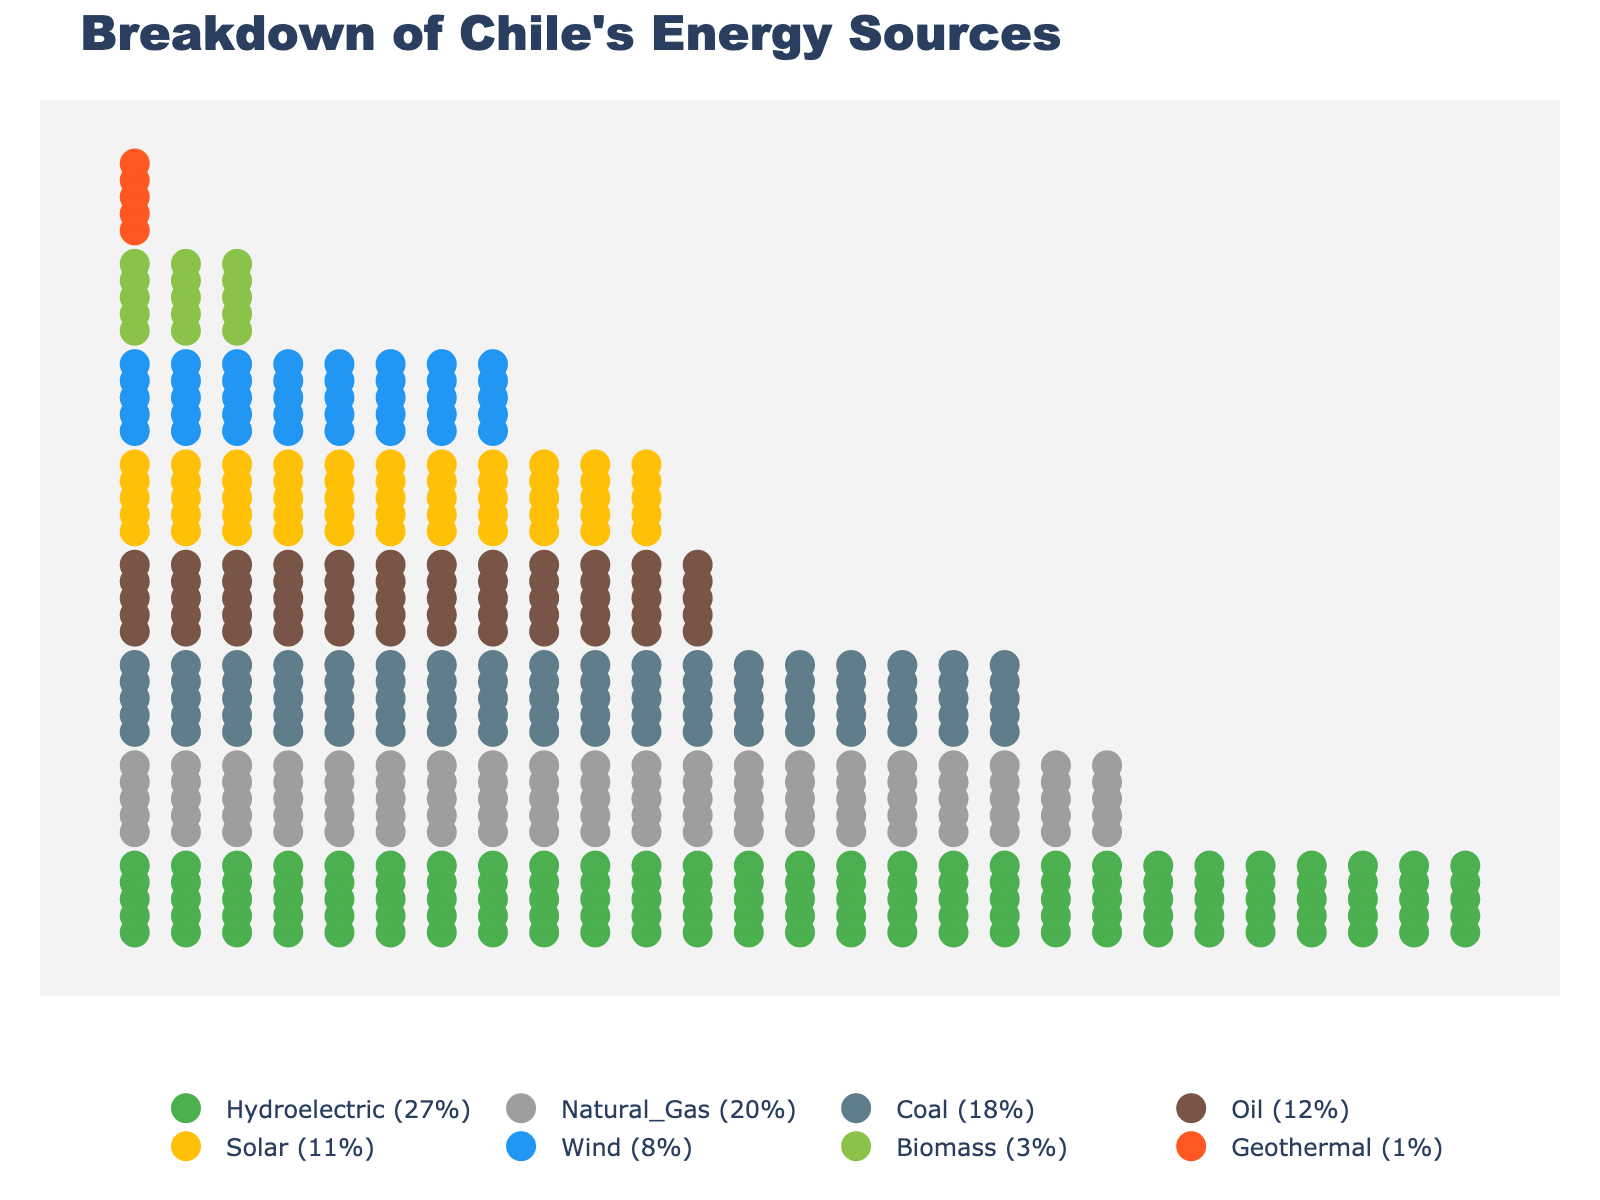what is the title of the plot? The title is usually prominently displayed at the top of the isotype plot. Look for large bold text.
Answer: Breakdown of Chile's Energy Sources Which energy source has the highest percentage? The energy source with the highest percentage will have the most icons arranged horizontally.
Answer: Hydroelectric How many types of renewable energy sources are represented in the plot? Count the different renewable energy sources displayed in the plot. Renewables typically include hydroelectric, solar, wind, biomass, and geothermal.
Answer: 5 What is the total percentage of energy coming from non-renewable sources? Add the percentages of natural gas, coal, and oil.
Answer: 20% + 18% + 12% = 50% Which renewable energy source contributes the least to Chile's energy breakdown? Look for the renewable source with the fewest icons.
Answer: Geothermal How does the percentage of solar energy compare to the percentage of oil energy? Compare the number of icons (or the percentages) representing solar energy and oil energy.
Answer: Solar has 11%, while Oil has 12%. Solar is 1% less than Oil What are the combined percentages of coal and natural gas? Sum the percentages of coal and natural gas.
Answer: 18% + 20% = 38% Which non-renewable source has the smallest percentage? Identify the non-renewable source with the fewest icons or lowest percentage.
Answer: Oil If we add the percentages of solar and wind energy, what do we get? Sum the percentages of solar and wind energy.
Answer: 11% + 8% = 19% How many times greater is the percentage of hydroelectric energy compared to geothermal energy? Divide the percentage of hydroelectric energy by the percentage of geothermal energy.
Answer: 27% / 1% = 27 times 